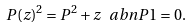Convert formula to latex. <formula><loc_0><loc_0><loc_500><loc_500>P ( z ) ^ { 2 } = P ^ { 2 } + z \ a b { n } { P } { 1 } = 0 .</formula> 